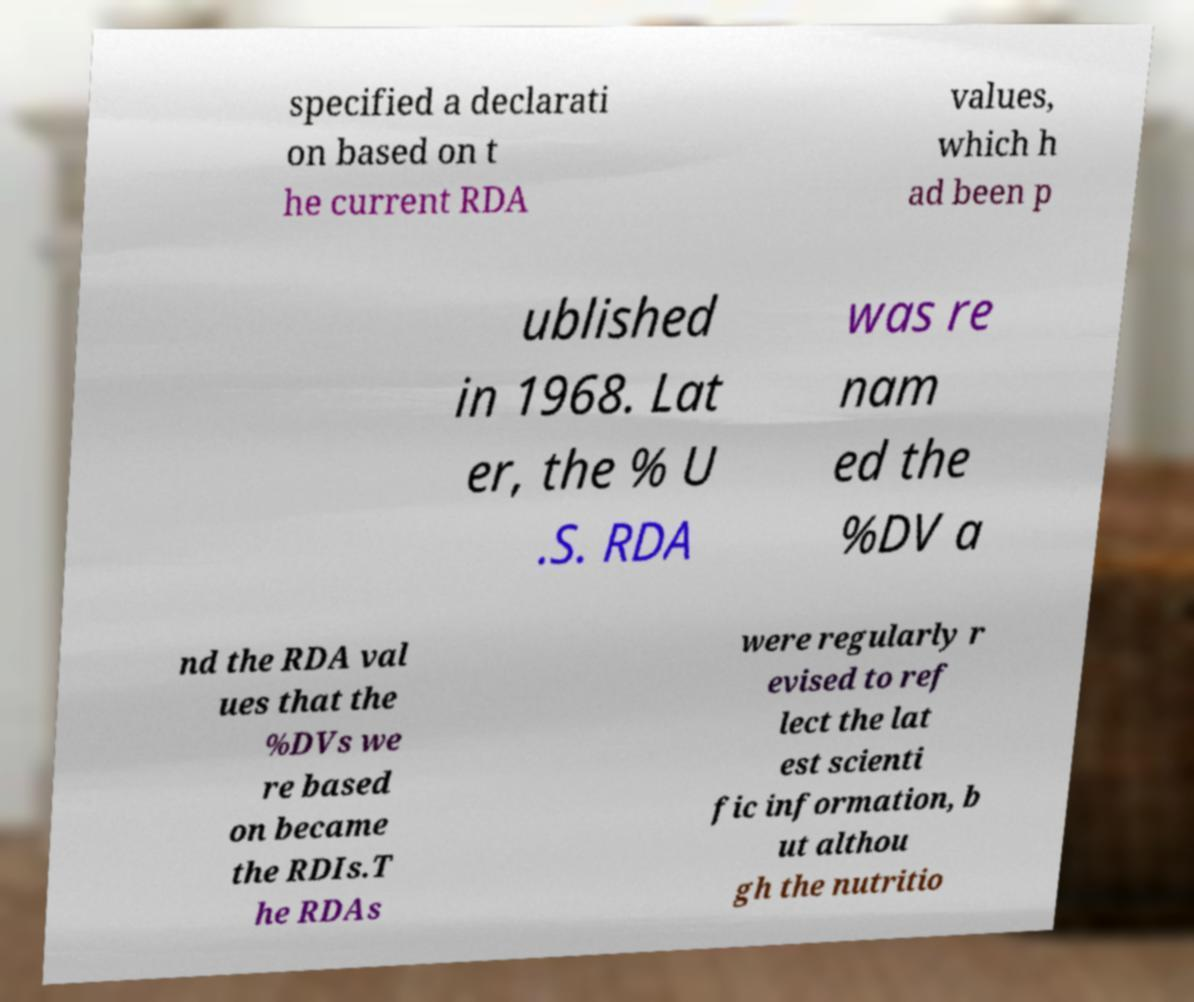What messages or text are displayed in this image? I need them in a readable, typed format. specified a declarati on based on t he current RDA values, which h ad been p ublished in 1968. Lat er, the % U .S. RDA was re nam ed the %DV a nd the RDA val ues that the %DVs we re based on became the RDIs.T he RDAs were regularly r evised to ref lect the lat est scienti fic information, b ut althou gh the nutritio 